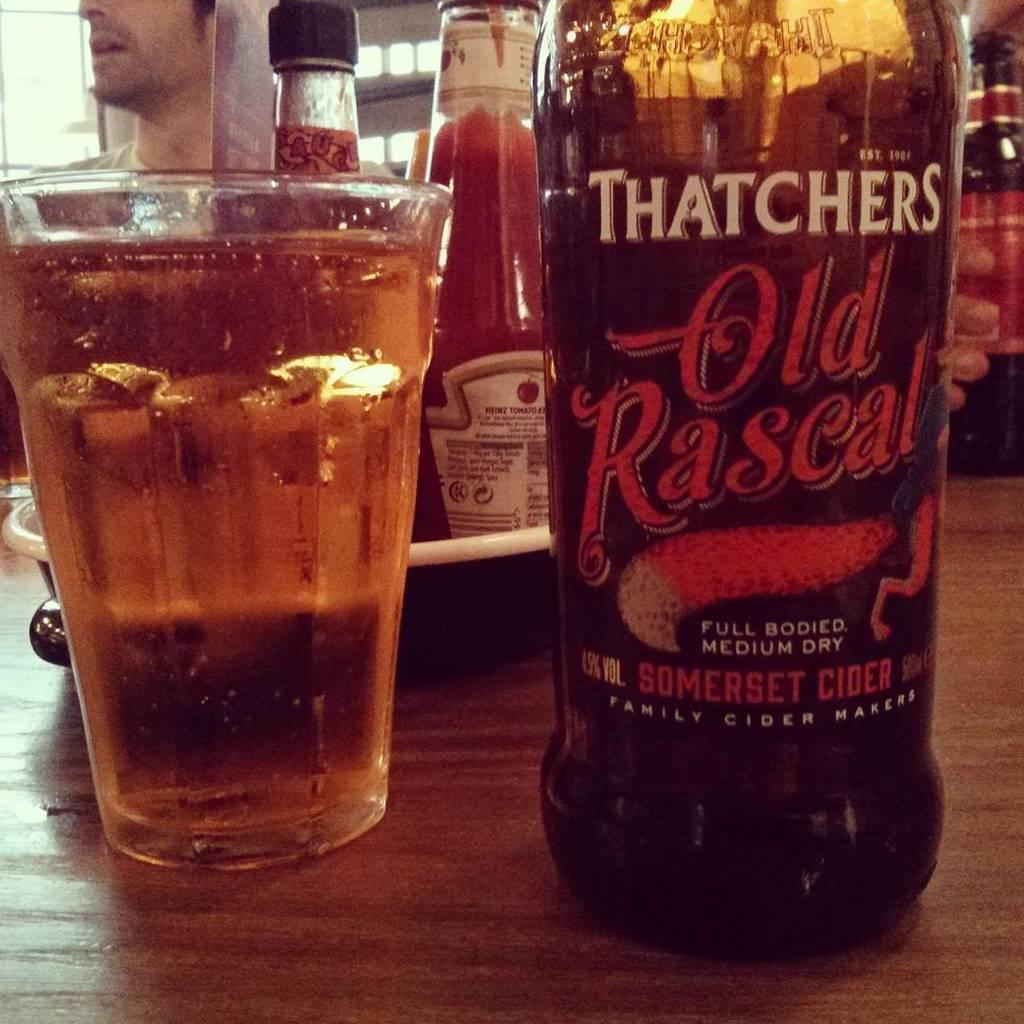<image>
Provide a brief description of the given image. the word Old that is on a bottle on the table 